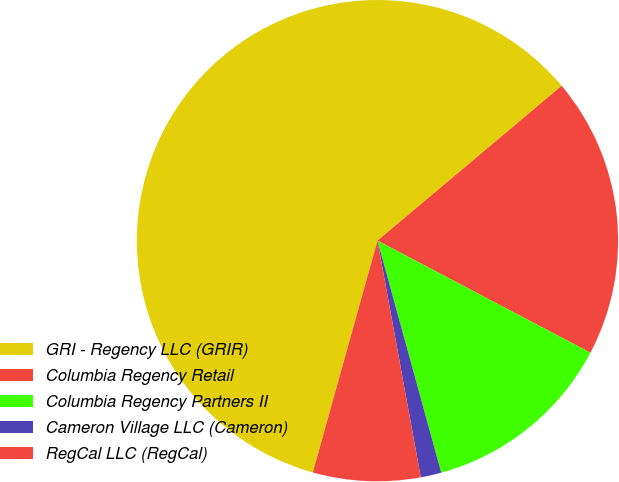Convert chart. <chart><loc_0><loc_0><loc_500><loc_500><pie_chart><fcel>GRI - Regency LLC (GRIR)<fcel>Columbia Regency Retail<fcel>Columbia Regency Partners II<fcel>Cameron Village LLC (Cameron)<fcel>RegCal LLC (RegCal)<nl><fcel>59.55%<fcel>18.84%<fcel>13.02%<fcel>1.39%<fcel>7.21%<nl></chart> 